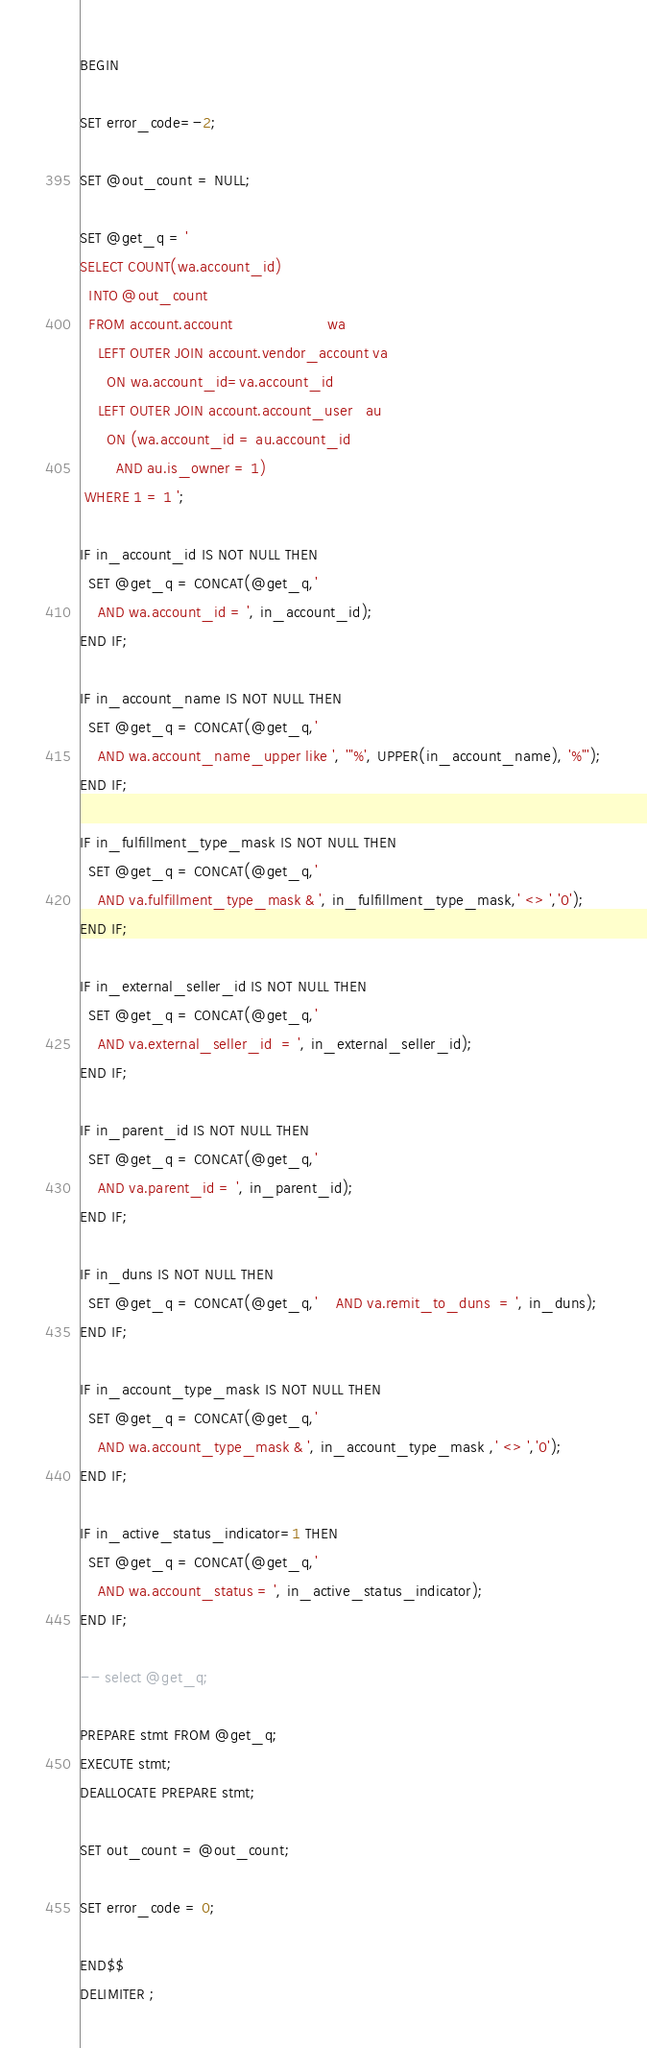Convert code to text. <code><loc_0><loc_0><loc_500><loc_500><_SQL_>BEGIN

SET error_code=-2;

SET @out_count = NULL;

SET @get_q = '
SELECT COUNT(wa.account_id)
  INTO @out_count
  FROM account.account                     wa 
    LEFT OUTER JOIN account.vendor_account va
      ON wa.account_id=va.account_id
    LEFT OUTER JOIN account.account_user   au
      ON (wa.account_id = au.account_id
        AND au.is_owner = 1)
 WHERE 1 = 1 ';

IF in_account_id IS NOT NULL THEN 
  SET @get_q = CONCAT(@get_q,'
    AND wa.account_id = ', in_account_id);
END IF; 

IF in_account_name IS NOT NULL THEN 
  SET @get_q = CONCAT(@get_q,'
    AND wa.account_name_upper like ', '"%', UPPER(in_account_name), '%"');
END IF;

IF in_fulfillment_type_mask IS NOT NULL THEN 
  SET @get_q = CONCAT(@get_q,'
    AND va.fulfillment_type_mask & ', in_fulfillment_type_mask,' <> ','0'); 
END IF;

IF in_external_seller_id IS NOT NULL THEN 
  SET @get_q = CONCAT(@get_q,'
    AND va.external_seller_id  = ', in_external_seller_id);
END IF;

IF in_parent_id IS NOT NULL THEN 
  SET @get_q = CONCAT(@get_q,'
    AND va.parent_id = ', in_parent_id);
END IF; 

IF in_duns IS NOT NULL THEN 
  SET @get_q = CONCAT(@get_q,'    AND va.remit_to_duns  = ', in_duns);
END IF;

IF in_account_type_mask IS NOT NULL THEN 
  SET @get_q = CONCAT(@get_q,'
    AND wa.account_type_mask & ', in_account_type_mask ,' <> ','0');
END IF; 

IF in_active_status_indicator=1 THEN 
  SET @get_q = CONCAT(@get_q,'
    AND wa.account_status = ', in_active_status_indicator);
END IF;

-- select @get_q;

PREPARE stmt FROM @get_q;
EXECUTE stmt;
DEALLOCATE PREPARE stmt;

SET out_count = @out_count;

SET error_code = 0;

END$$
DELIMITER ;</code> 